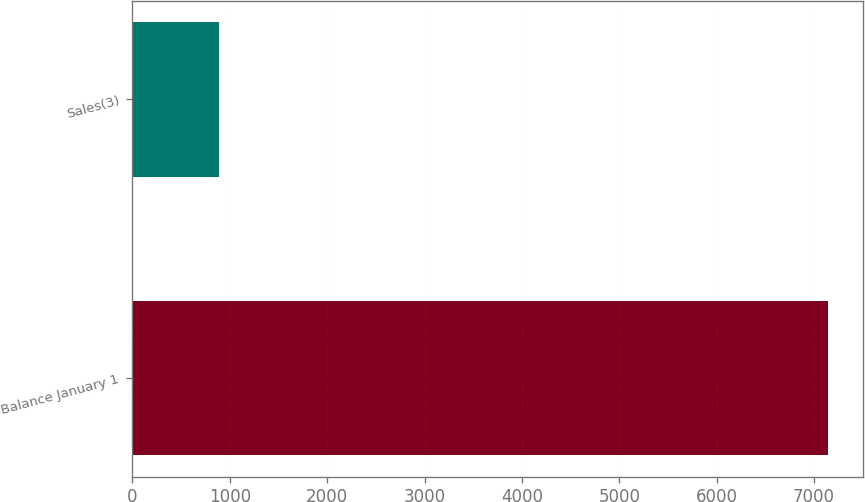Convert chart to OTSL. <chart><loc_0><loc_0><loc_500><loc_500><bar_chart><fcel>Balance January 1<fcel>Sales(3)<nl><fcel>7149<fcel>887<nl></chart> 